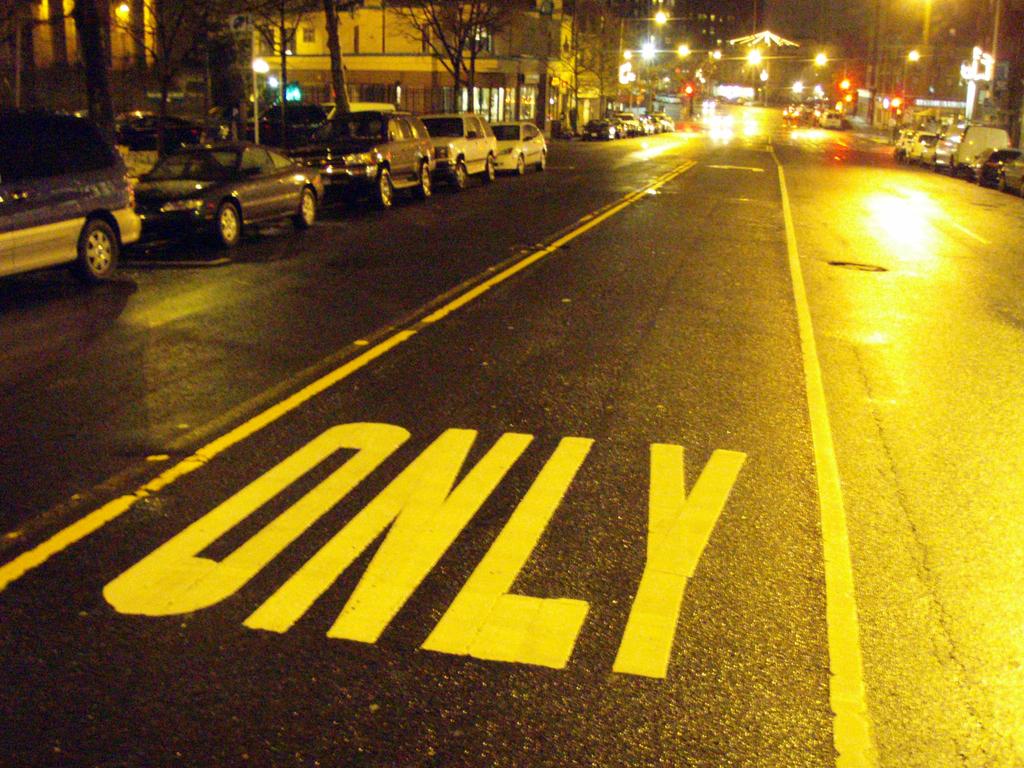What is written in the street lane?
Offer a terse response. Only. 